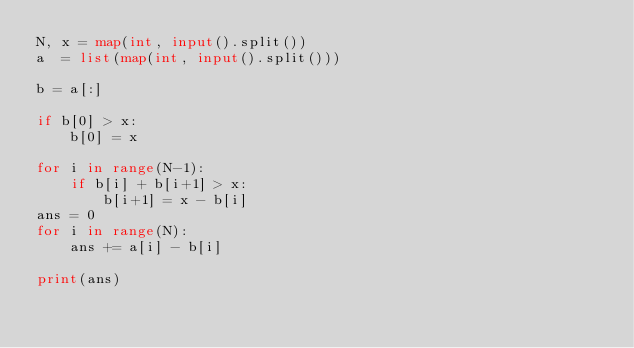<code> <loc_0><loc_0><loc_500><loc_500><_Python_>N, x = map(int, input().split())
a  = list(map(int, input().split()))

b = a[:]

if b[0] > x:
    b[0] = x

for i in range(N-1):
    if b[i] + b[i+1] > x:
        b[i+1] = x - b[i]
ans = 0
for i in range(N):
    ans += a[i] - b[i]

print(ans)
</code> 